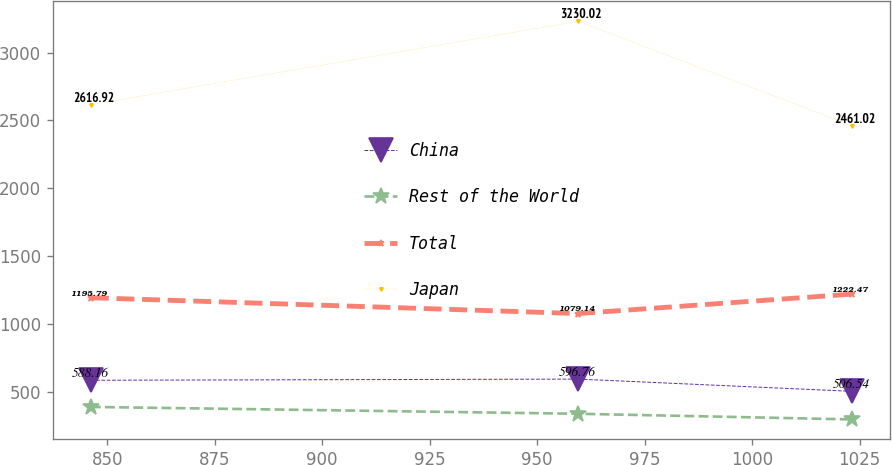Convert chart. <chart><loc_0><loc_0><loc_500><loc_500><line_chart><ecel><fcel>China<fcel>Rest of the World<fcel>Total<fcel>Japan<nl><fcel>846.19<fcel>588.16<fcel>391.98<fcel>1195.79<fcel>2616.92<nl><fcel>959.61<fcel>596.76<fcel>341.62<fcel>1079.14<fcel>3230.02<nl><fcel>1023.29<fcel>506.54<fcel>300<fcel>1222.47<fcel>2461.02<nl></chart> 